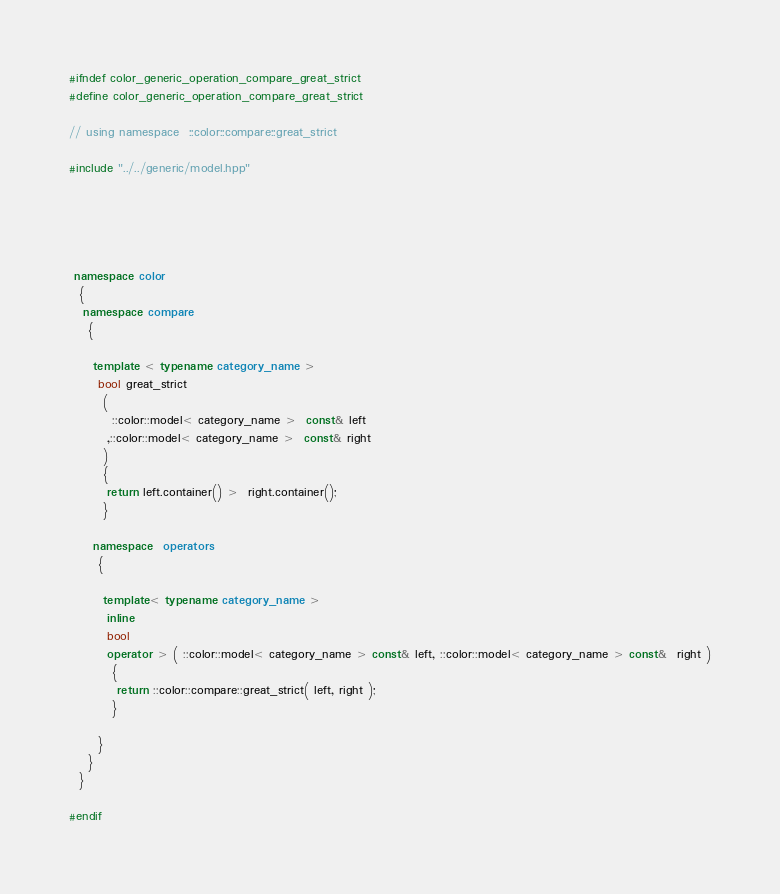Convert code to text. <code><loc_0><loc_0><loc_500><loc_500><_C++_>#ifndef color_generic_operation_compare_great_strict
#define color_generic_operation_compare_great_strict

// using namespace  ::color::compare::great_strict

#include "../../generic/model.hpp"





 namespace color
  {
   namespace compare
    {

     template < typename category_name >
      bool great_strict
       (
         ::color::model< category_name >  const& left
        ,::color::model< category_name >  const& right
       )
       {
        return left.container() >  right.container();
       }

     namespace  operators
      {

       template< typename category_name >
        inline
        bool
        operator > ( ::color::model< category_name > const& left, ::color::model< category_name > const&  right )
         {
          return ::color::compare::great_strict( left, right );
         }

      }
    }
  }

#endif
</code> 